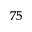Convert formula to latex. <formula><loc_0><loc_0><loc_500><loc_500>^ { 7 5 }</formula> 